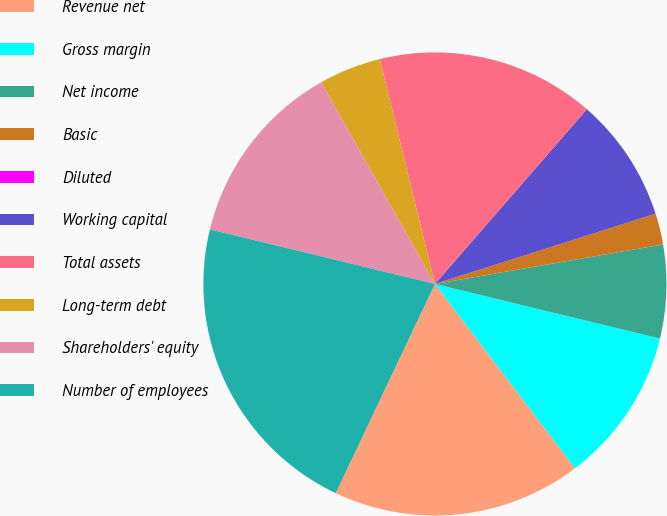Convert chart to OTSL. <chart><loc_0><loc_0><loc_500><loc_500><pie_chart><fcel>Revenue net<fcel>Gross margin<fcel>Net income<fcel>Basic<fcel>Diluted<fcel>Working capital<fcel>Total assets<fcel>Long-term debt<fcel>Shareholders' equity<fcel>Number of employees<nl><fcel>17.39%<fcel>10.87%<fcel>6.52%<fcel>2.18%<fcel>0.0%<fcel>8.7%<fcel>15.22%<fcel>4.35%<fcel>13.04%<fcel>21.74%<nl></chart> 